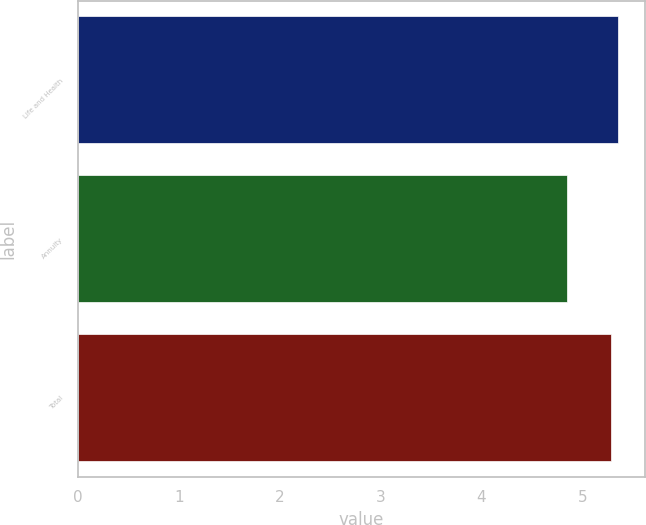<chart> <loc_0><loc_0><loc_500><loc_500><bar_chart><fcel>Life and Health<fcel>Annuity<fcel>Total<nl><fcel>5.35<fcel>4.85<fcel>5.28<nl></chart> 